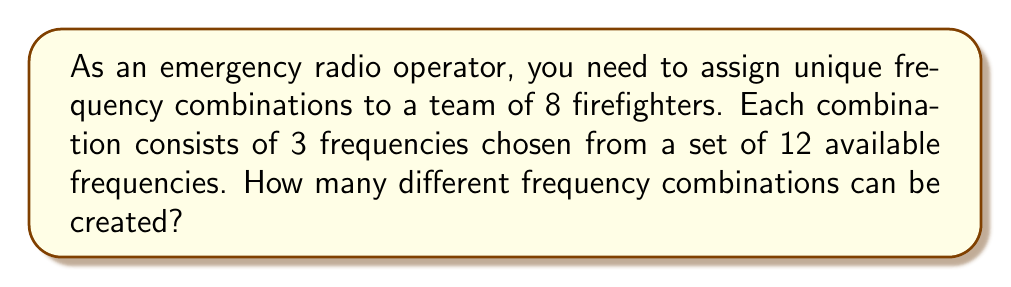Show me your answer to this math problem. To solve this problem, we need to use the concept of permutations without repetition. Here's a step-by-step explanation:

1. We are selecting 3 frequencies out of 12 available frequencies.
2. The order of selection matters (as it creates a unique combination).
3. We cannot use the same frequency more than once in a combination.

This scenario fits the formula for permutations without repetition:

$$ P(n,r) = \frac{n!}{(n-r)!} $$

Where:
$n$ = total number of items to choose from (12 frequencies)
$r$ = number of items being chosen (3 frequencies)

Let's plug in the values:

$$ P(12,3) = \frac{12!}{(12-3)!} = \frac{12!}{9!} $$

Expanding this:

$$ \frac{12 \cdot 11 \cdot 10 \cdot 9!}{9!} $$

The $9!$ cancels out in the numerator and denominator:

$$ 12 \cdot 11 \cdot 10 = 1320 $$

Therefore, there are 1320 possible unique frequency combinations that can be created for the firefighters.
Answer: 1320 possible frequency combinations 